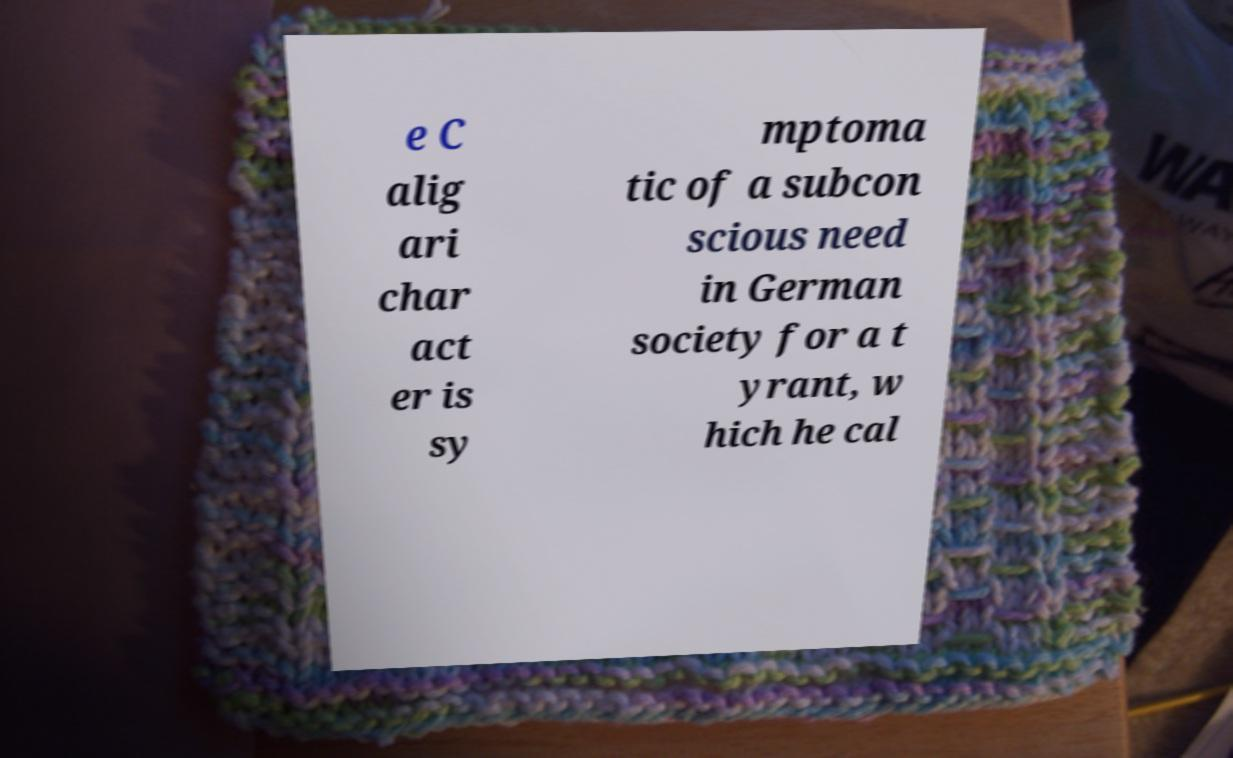Please identify and transcribe the text found in this image. e C alig ari char act er is sy mptoma tic of a subcon scious need in German society for a t yrant, w hich he cal 